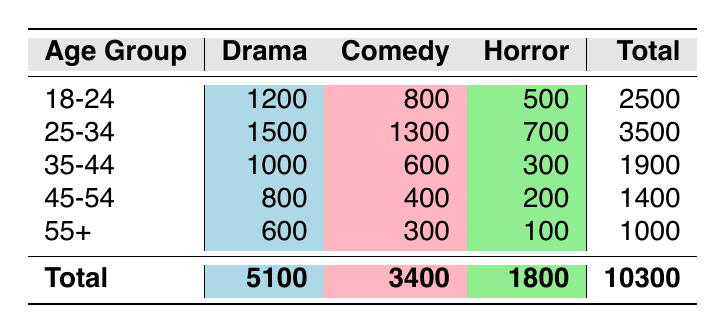What's the total audience count for the 18-24 age group? To find the total audience count for the 18-24 age group, we sum up the values in that row: 1200 (Drama) + 800 (Comedy) + 500 (Horror) = 2500.
Answer: 2500 How many people attended Horror screenings in the 25-34 age group? The audience count for Horror in the 25-34 age group is directly provided in the table, which is 700.
Answer: 700 Which age group had the highest audience count for Comedy films? By comparing the Comedy audience counts for each age group, we see that the highest is in the 25-34 age group with 1300.
Answer: 25-34 Is the audience count for Drama screenings across all age groups greater than 5000? First, we need the total audience count for Drama screenings, which is 5100. Since 5100 is greater than 5000, the statement is true.
Answer: Yes What is the difference in the total audience count between the 35-44 and 45-54 age groups? The total for 35-44 is 1900 and for 45-54 it is 1400. Calculating the difference: 1900 - 1400 = 500.
Answer: 500 What genre did the 55+ age group prefer the least, and what is the audience count for that genre? Looking at the audience counts for the 55+ age group, Horror has the lowest count with 100, compared to Drama (600) and Comedy (300).
Answer: Horror, 100 Which genre has the lowest total audience count across all age groups, and what is that count? To find the lowest total, we sum the audience counts: Drama (5100) + Comedy (3400) + Horror (1800). The lowest is Horror with a total of 1800.
Answer: Horror, 1800 How many more people attended Comedy screenings than Horror screenings in the 45-54 age group? The audience count for Comedy in the 45-54 age group is 400, and for Horror, it is 200. The difference is 400 - 200 = 200.
Answer: 200 